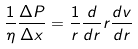<formula> <loc_0><loc_0><loc_500><loc_500>\frac { 1 } { \eta } \frac { \Delta P } { \Delta x } = \frac { 1 } { r } \frac { d } { d r } r \frac { d v } { d r }</formula> 